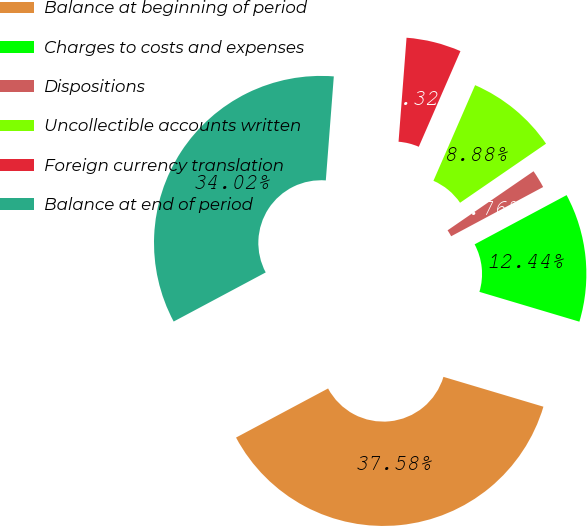<chart> <loc_0><loc_0><loc_500><loc_500><pie_chart><fcel>Balance at beginning of period<fcel>Charges to costs and expenses<fcel>Dispositions<fcel>Uncollectible accounts written<fcel>Foreign currency translation<fcel>Balance at end of period<nl><fcel>37.59%<fcel>12.44%<fcel>1.76%<fcel>8.88%<fcel>5.32%<fcel>34.03%<nl></chart> 